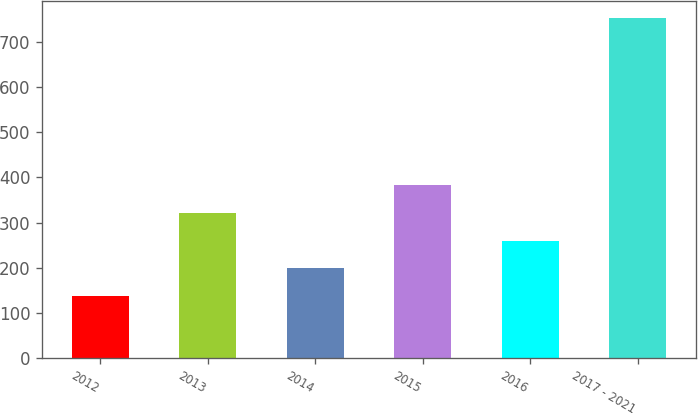Convert chart to OTSL. <chart><loc_0><loc_0><loc_500><loc_500><bar_chart><fcel>2012<fcel>2013<fcel>2014<fcel>2015<fcel>2016<fcel>2017 - 2021<nl><fcel>137<fcel>321.8<fcel>198.6<fcel>383.4<fcel>260.2<fcel>753<nl></chart> 